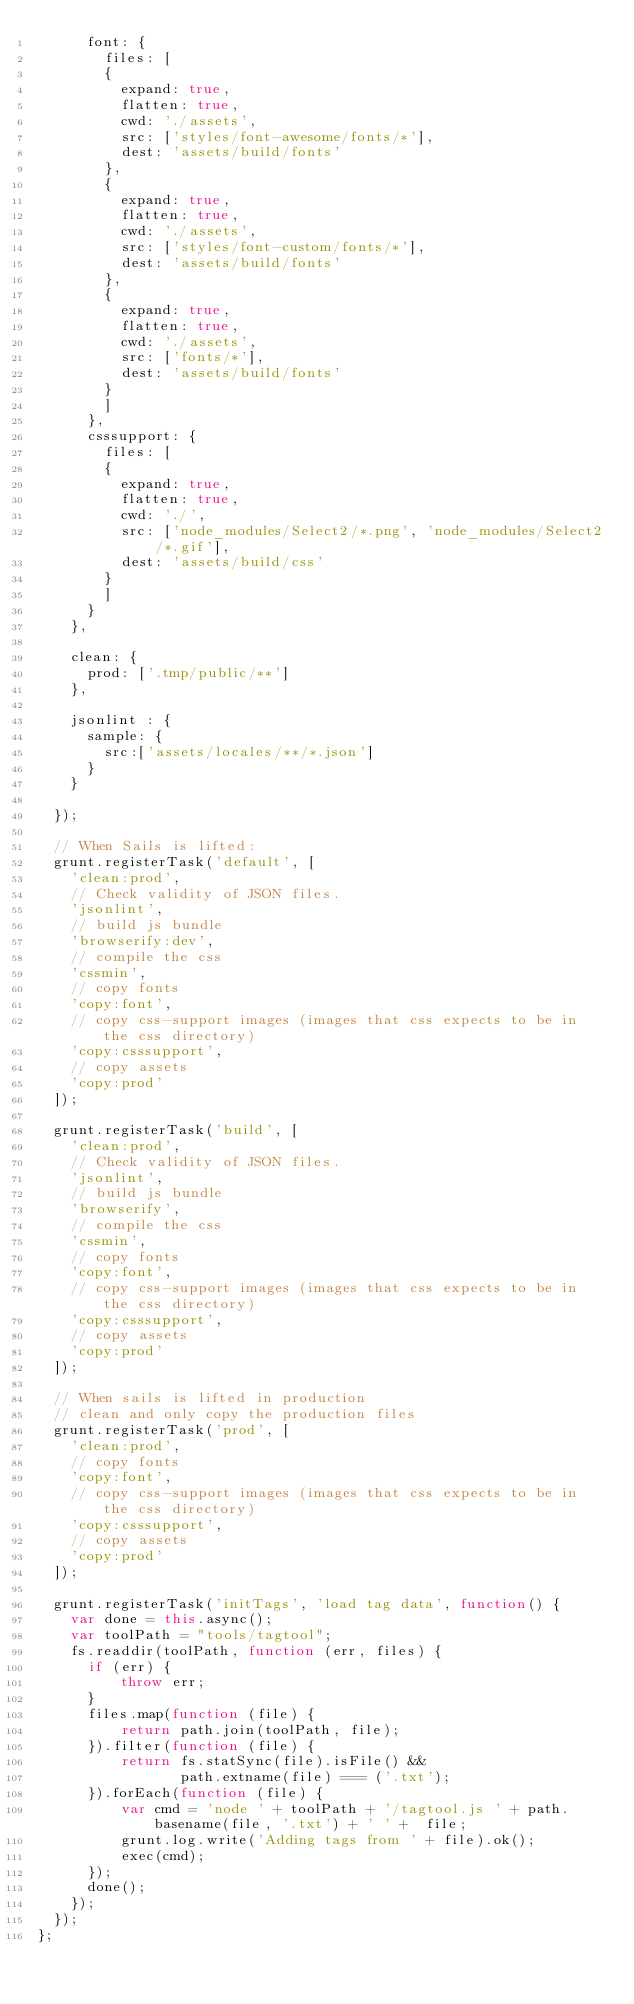Convert code to text. <code><loc_0><loc_0><loc_500><loc_500><_JavaScript_>      font: {
        files: [
        {
          expand: true,
          flatten: true,
          cwd: './assets',
          src: ['styles/font-awesome/fonts/*'],
          dest: 'assets/build/fonts'
        },
        {
          expand: true,
          flatten: true,
          cwd: './assets',
          src: ['styles/font-custom/fonts/*'],
          dest: 'assets/build/fonts'
        },
        {
          expand: true,
          flatten: true,
          cwd: './assets',
          src: ['fonts/*'],
          dest: 'assets/build/fonts'
        }
        ]
      },
      csssupport: {
        files: [
        {
          expand: true,
          flatten: true,
          cwd: './',
          src: ['node_modules/Select2/*.png', 'node_modules/Select2/*.gif'],
          dest: 'assets/build/css'
        }
        ]
      }
    },

    clean: {
      prod: ['.tmp/public/**']
    },

    jsonlint : {
      sample: {
        src:['assets/locales/**/*.json']
      }
    }

  });

  // When Sails is lifted:
  grunt.registerTask('default', [
    'clean:prod',
    // Check validity of JSON files.
    'jsonlint',
    // build js bundle
    'browserify:dev',
    // compile the css
    'cssmin',
    // copy fonts
    'copy:font',
    // copy css-support images (images that css expects to be in the css directory)
    'copy:csssupport',
    // copy assets
    'copy:prod'
  ]);

  grunt.registerTask('build', [
    'clean:prod',
    // Check validity of JSON files.
    'jsonlint',
    // build js bundle
    'browserify',
    // compile the css
    'cssmin',
    // copy fonts
    'copy:font',
    // copy css-support images (images that css expects to be in the css directory)
    'copy:csssupport',
    // copy assets
    'copy:prod'
  ]);

  // When sails is lifted in production
  // clean and only copy the production files
  grunt.registerTask('prod', [
    'clean:prod',
    // copy fonts
    'copy:font',
    // copy css-support images (images that css expects to be in the css directory)
    'copy:csssupport',
    // copy assets
    'copy:prod'
  ]);

  grunt.registerTask('initTags', 'load tag data', function() {
    var done = this.async();
    var toolPath = "tools/tagtool";
    fs.readdir(toolPath, function (err, files) {
      if (err) {
          throw err;
      }
      files.map(function (file) {
          return path.join(toolPath, file);
      }).filter(function (file) {
          return fs.statSync(file).isFile() &&
                 path.extname(file) === ('.txt');
      }).forEach(function (file) {
          var cmd = 'node ' + toolPath + '/tagtool.js ' + path.basename(file, '.txt') + ' ' +  file;
          grunt.log.write('Adding tags from ' + file).ok();
          exec(cmd);
      });
      done();
    });
  });
};
</code> 